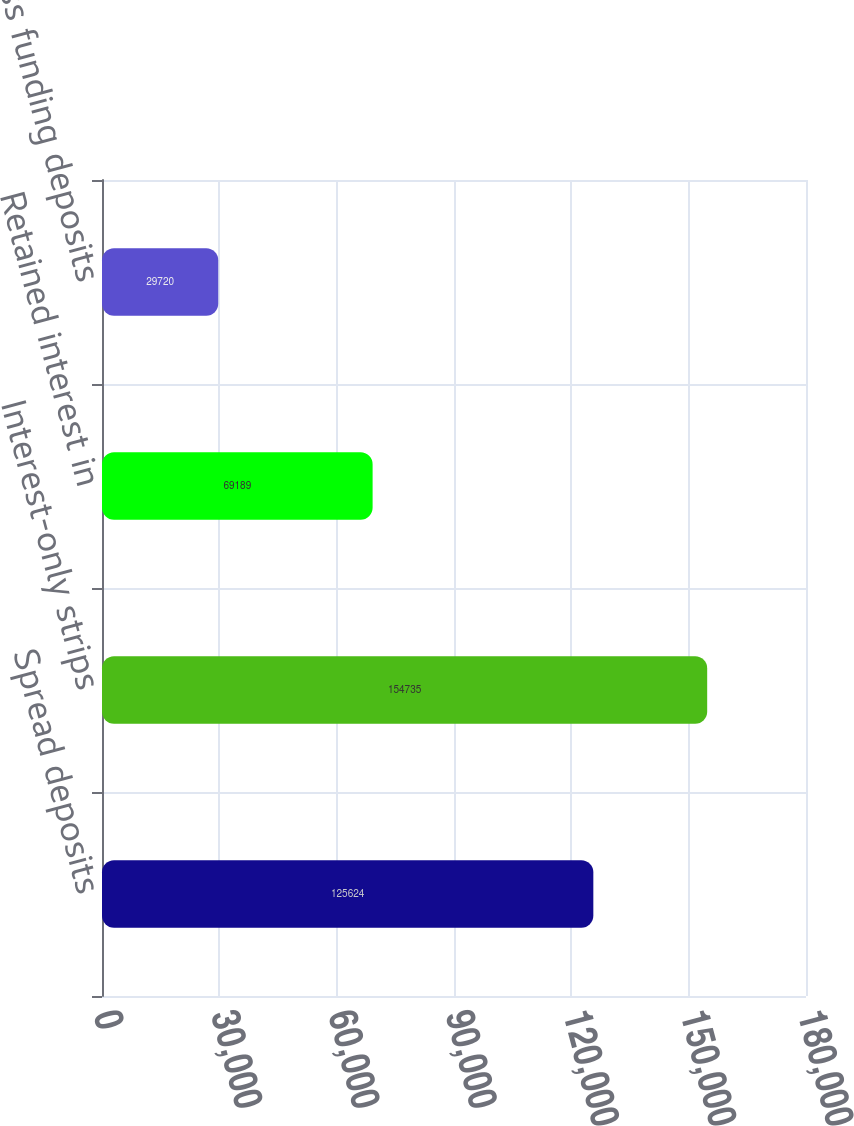<chart> <loc_0><loc_0><loc_500><loc_500><bar_chart><fcel>Spread deposits<fcel>Interest-only strips<fcel>Retained interest in<fcel>Excess funding deposits<nl><fcel>125624<fcel>154735<fcel>69189<fcel>29720<nl></chart> 